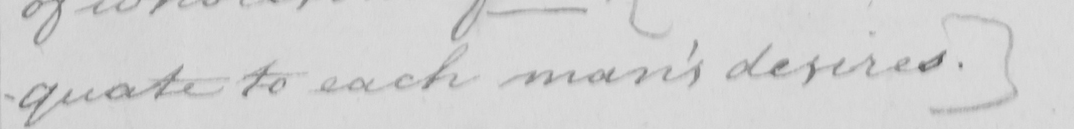What does this handwritten line say? -quate to each man ' s desires . ] 